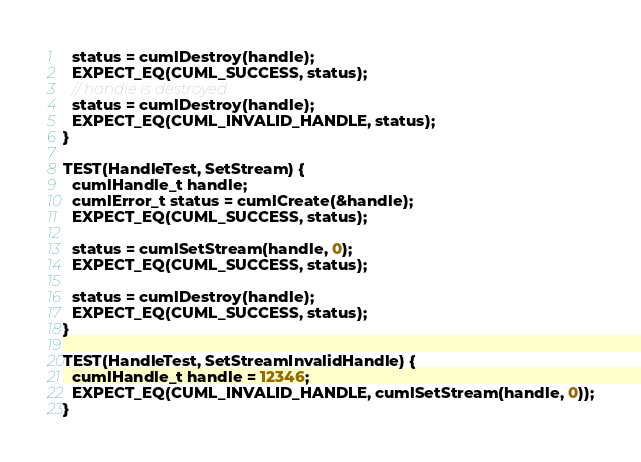Convert code to text. <code><loc_0><loc_0><loc_500><loc_500><_Cuda_>  status = cumlDestroy(handle);
  EXPECT_EQ(CUML_SUCCESS, status);
  // handle is destroyed
  status = cumlDestroy(handle);
  EXPECT_EQ(CUML_INVALID_HANDLE, status);
}

TEST(HandleTest, SetStream) {
  cumlHandle_t handle;
  cumlError_t status = cumlCreate(&handle);
  EXPECT_EQ(CUML_SUCCESS, status);

  status = cumlSetStream(handle, 0);
  EXPECT_EQ(CUML_SUCCESS, status);

  status = cumlDestroy(handle);
  EXPECT_EQ(CUML_SUCCESS, status);
}

TEST(HandleTest, SetStreamInvalidHandle) {
  cumlHandle_t handle = 12346;
  EXPECT_EQ(CUML_INVALID_HANDLE, cumlSetStream(handle, 0));
}
</code> 